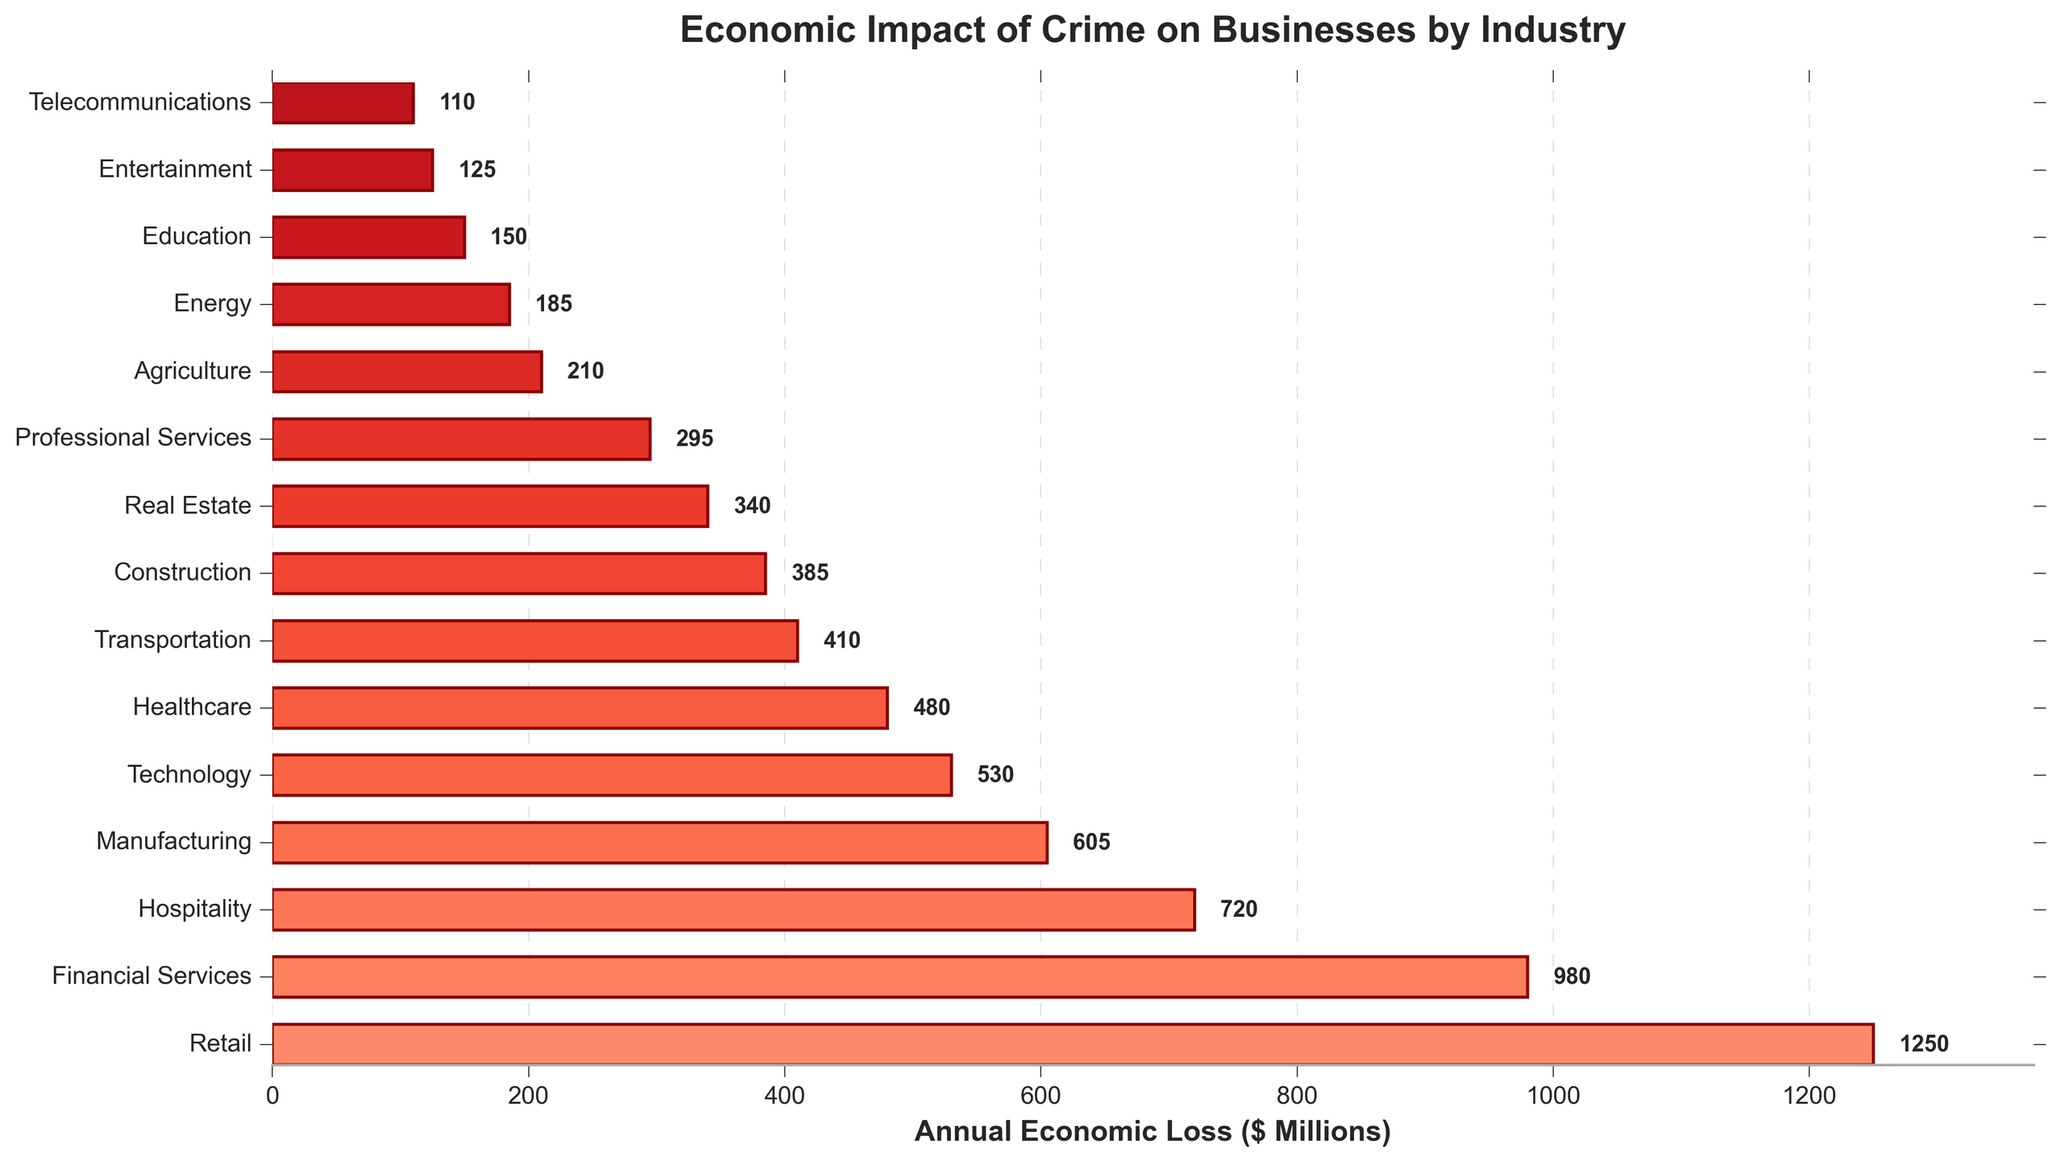What is the total annual economic loss for the retail and financial services sectors? To find the total annual economic loss for the retail and financial services sectors, add the losses of these two sectors: 1250 (Retail) + 980 (Financial Services).
Answer: 2230 Which industry sector experiences the highest economic loss due to crime? By looking at the lengths of the bars, the Retail sector has the longest bar which represents the highest economic loss among all sectors.
Answer: Retail How much greater is the annual economic loss in the healthcare sector compared to the transportation sector? The annual economic loss for the healthcare sector is 480 and for the transportation sector is 410. Subtract the transportation sector's loss from the healthcare sector's loss: 480 - 410.
Answer: 70 Order the top three sectors with the highest annual economic losses due to crime. By examining the chart, the top three sectors with the highest annual economic losses are: 1) Retail (1250), 2) Financial Services (980), and 3) Hospitality (720).
Answer: Retail, Financial Services, Hospitality What is the average annual economic loss of the sectors listed? To compute the average, sum all the annual economic losses and divide by the number of sectors. Total loss = 1250 + 980 + 720 + 605 + 530 + 480 + 410 + 385 + 340 + 295 + 210 + 185 + 150 + 125 + 110 = 6775. Number of sectors = 15. Average = 6775 / 15.
Answer: 451.67 Compare the economic loss of the construction sector and the entertainment sector. Does one suffer more than double the losses of the other? The construction sector has an annual economic loss of 385, and the entertainment sector has an annual economic loss of 125. Checking if the construction sector's loss is more than double the entertainment sector's loss: 385 > 2 * 125 = 250.
Answer: Yes, construction suffers more than double the losses of entertainment How much economic loss is incurred by the technology and real estate sectors combined? Add the economic losses of the technology sector (530) and the real estate sector (340): 530 + 340.
Answer: 870 Which sector has the least annual economic loss, and what is the value? The sector with the shortest bar, thus the least economic loss, is Telecommunications with a value of 110.
Answer: Telecommunications, 110 How many sectors have an annual economic loss greater than 500 million dollars? By evaluating the bars representing losses, there are four sectors with greater than 500 million dollars loss: Retail (1250), Financial Services (980), Hospitality (720), Manufacturing (605).
Answer: 4 